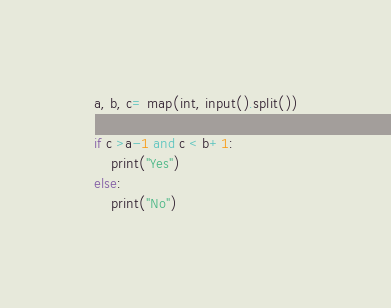<code> <loc_0><loc_0><loc_500><loc_500><_Python_>a, b, c= map(int, input().split())

if c >a-1 and c < b+1:
    print("Yes")
else:
    print("No")</code> 